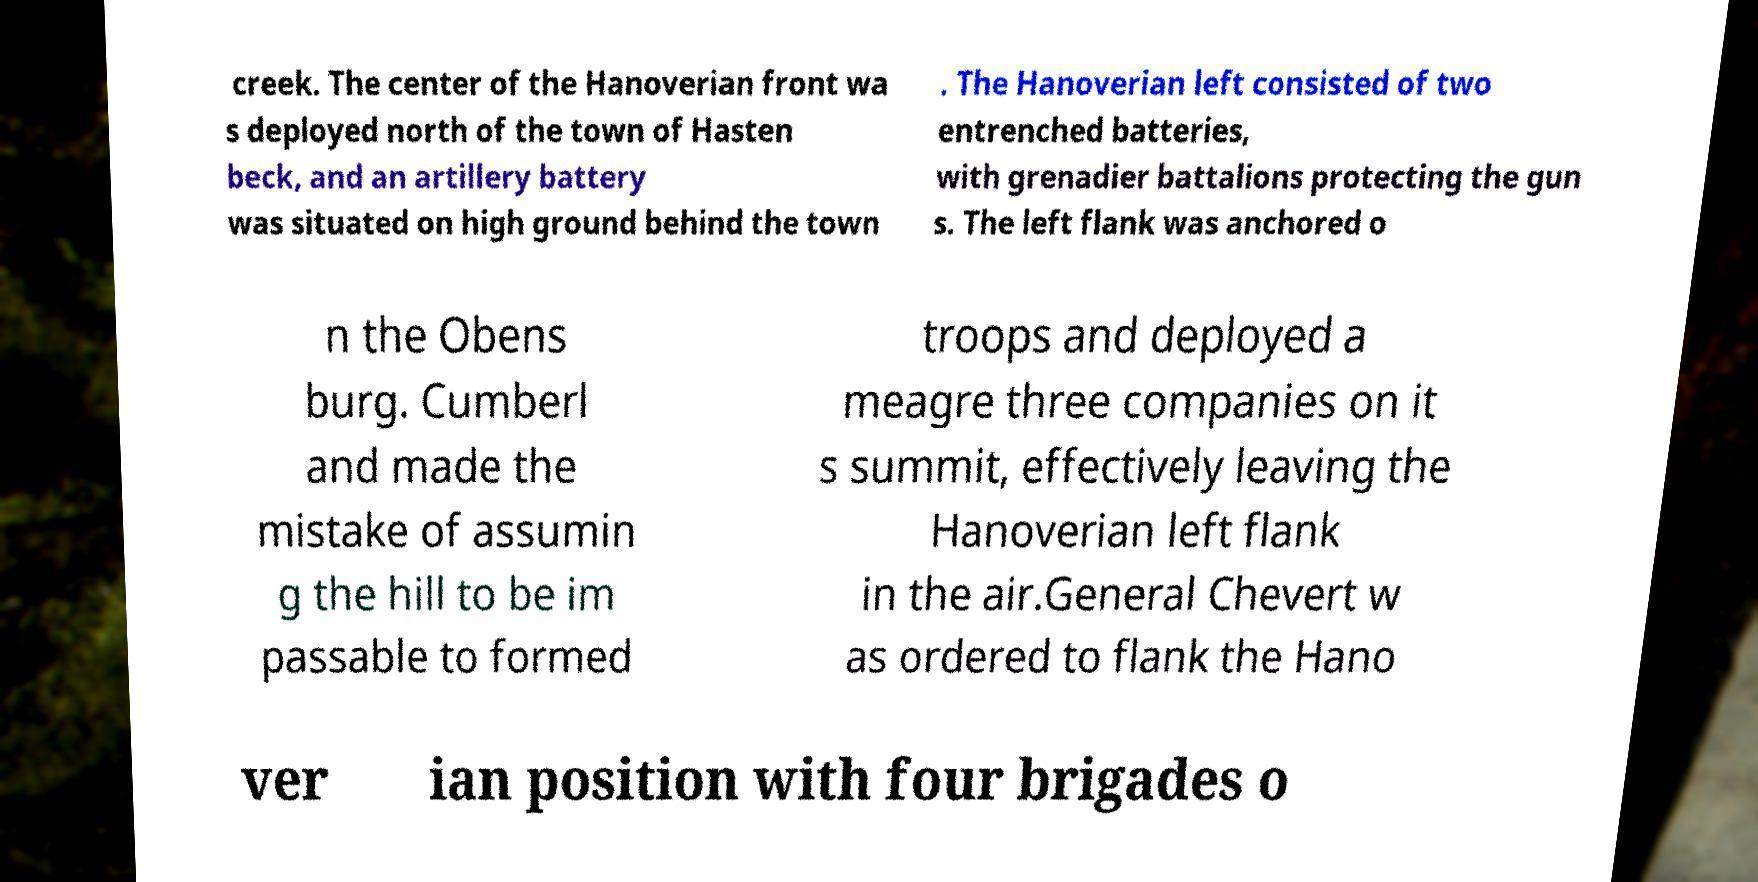There's text embedded in this image that I need extracted. Can you transcribe it verbatim? creek. The center of the Hanoverian front wa s deployed north of the town of Hasten beck, and an artillery battery was situated on high ground behind the town . The Hanoverian left consisted of two entrenched batteries, with grenadier battalions protecting the gun s. The left flank was anchored o n the Obens burg. Cumberl and made the mistake of assumin g the hill to be im passable to formed troops and deployed a meagre three companies on it s summit, effectively leaving the Hanoverian left flank in the air.General Chevert w as ordered to flank the Hano ver ian position with four brigades o 